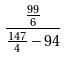Convert formula to latex. <formula><loc_0><loc_0><loc_500><loc_500>\frac { \frac { 9 9 } { 6 } } { \frac { 1 4 7 } { 4 } - 9 4 }</formula> 